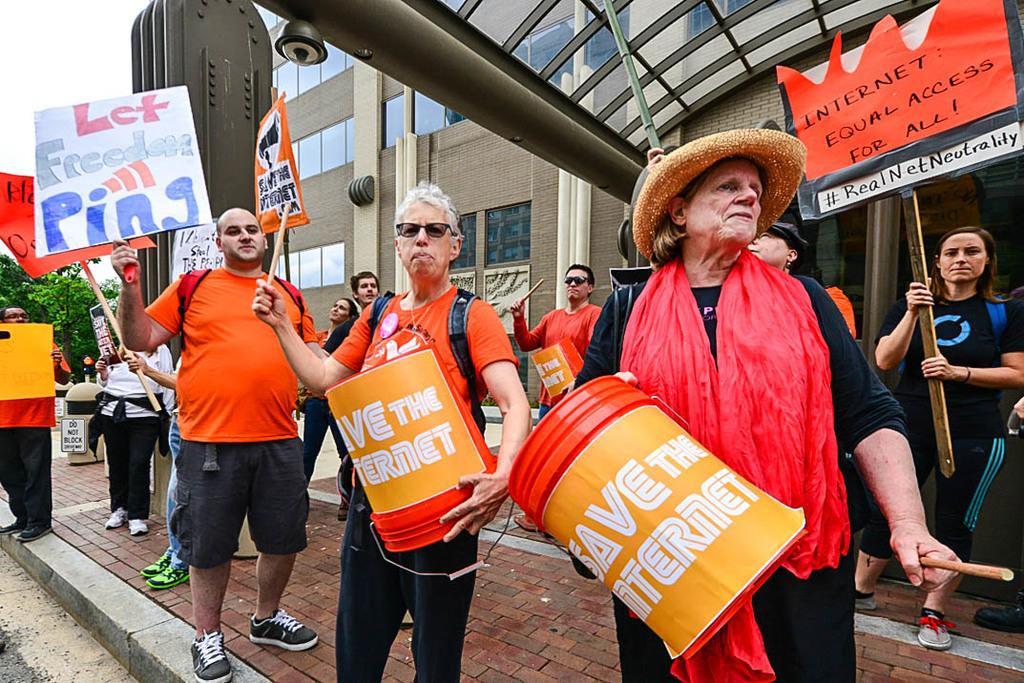What activity are the people in the image engaged in? The people in the image are playing drums. What else are the people holding in the image? The people are also holding boards. What can be seen in the background of the image? Buildings are visible in the background of the image. How does the heart shape fit into the image? There is no heart shape present in the image. What role does love play in the image? Love is not depicted or mentioned in the image. 